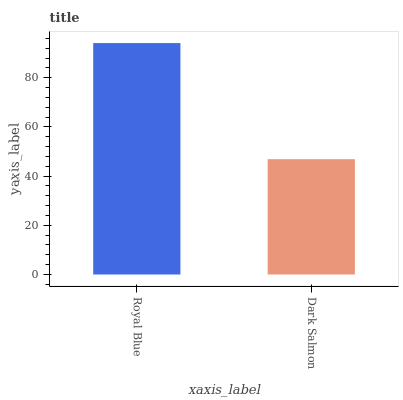Is Dark Salmon the minimum?
Answer yes or no. Yes. Is Royal Blue the maximum?
Answer yes or no. Yes. Is Dark Salmon the maximum?
Answer yes or no. No. Is Royal Blue greater than Dark Salmon?
Answer yes or no. Yes. Is Dark Salmon less than Royal Blue?
Answer yes or no. Yes. Is Dark Salmon greater than Royal Blue?
Answer yes or no. No. Is Royal Blue less than Dark Salmon?
Answer yes or no. No. Is Royal Blue the high median?
Answer yes or no. Yes. Is Dark Salmon the low median?
Answer yes or no. Yes. Is Dark Salmon the high median?
Answer yes or no. No. Is Royal Blue the low median?
Answer yes or no. No. 